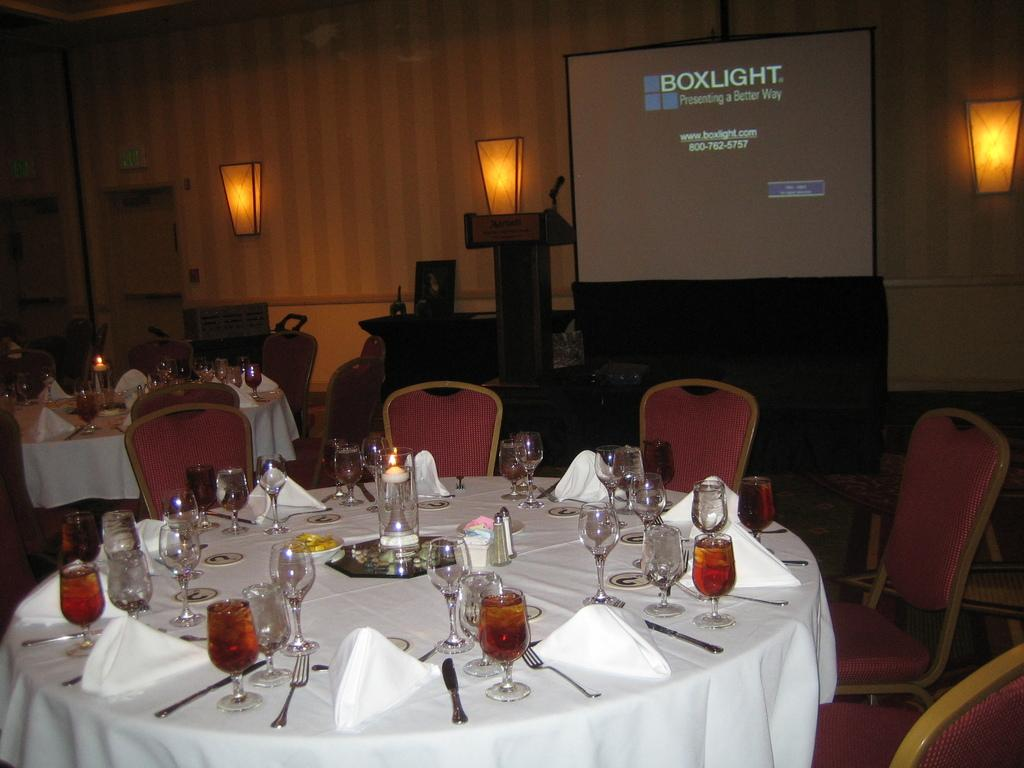<image>
Offer a succinct explanation of the picture presented. A banquet room set up with a large projection showcasing "Boxlight Presenting a better Way" on the screen/ 